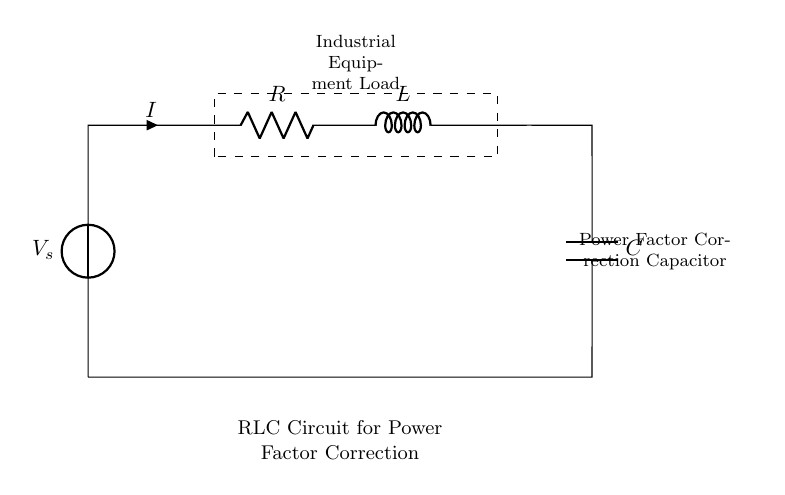What is the source voltage in this circuit? The source voltage, denoted as V_s, is the voltage supplied to the entire circuit. It is indicated in the diagram by the voltage source symbol next to the label.
Answer: V_s What type of load is represented in this circuit? The load is identified as "Industrial Equipment Load" within the dashed rectangle. This type of load typically includes machinery or devices used in industrial applications that consume electrical power.
Answer: Industrial Equipment Load What components are included in the circuit? The circuit comprises three main components: a resistor (R), an inductor (L), and a capacitor (C). Each component is labeled clearly in the circuit diagram, showing their respective placements.
Answer: Resistor, Inductor, Capacitor How is power factor correction achieved in this circuit? Power factor correction is accomplished by including the capacitor (C) in parallel with the load, which helps to offset the inductive effects of the load. This adjustment improves the overall power factor of the circuit, which is critical in industrial settings.
Answer: Capacitor What is the relationship between the resistor, inductor, and capacitor in terms of impedance? The impedance (Z) of this RLC circuit is determined by the combination of the resistor, inductor, and capacitor, where the total impedance is affected by the frequency of the signal and the values of each component. The formula is Z = R + j(X_L - X_C), where X_L is the inductive reactance and X_C is the capacitive reactance.
Answer: Impedance relationship How does this circuit help to reduce energy losses in industrial applications? By improving the power factor through power factor correction, this RLC circuit reduces reactive power, leading to lower line losses and better efficiency in power delivery. This is crucial for minimizing energy costs and optimizing the performance of industrial equipment.
Answer: Reducing reactive power 